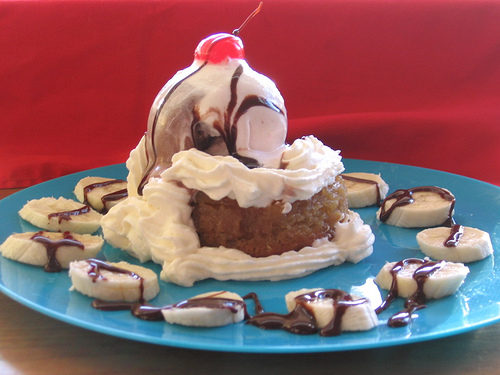<image>
Is the cherry on the chocolate? No. The cherry is not positioned on the chocolate. They may be near each other, but the cherry is not supported by or resting on top of the chocolate. 